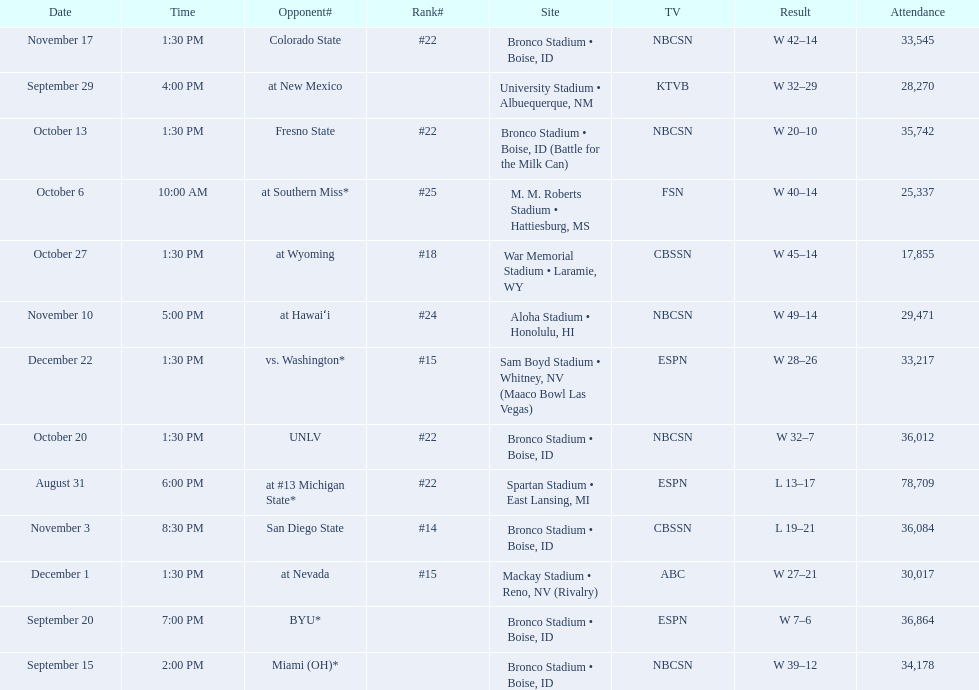What is the total number of games played at bronco stadium? 6. 